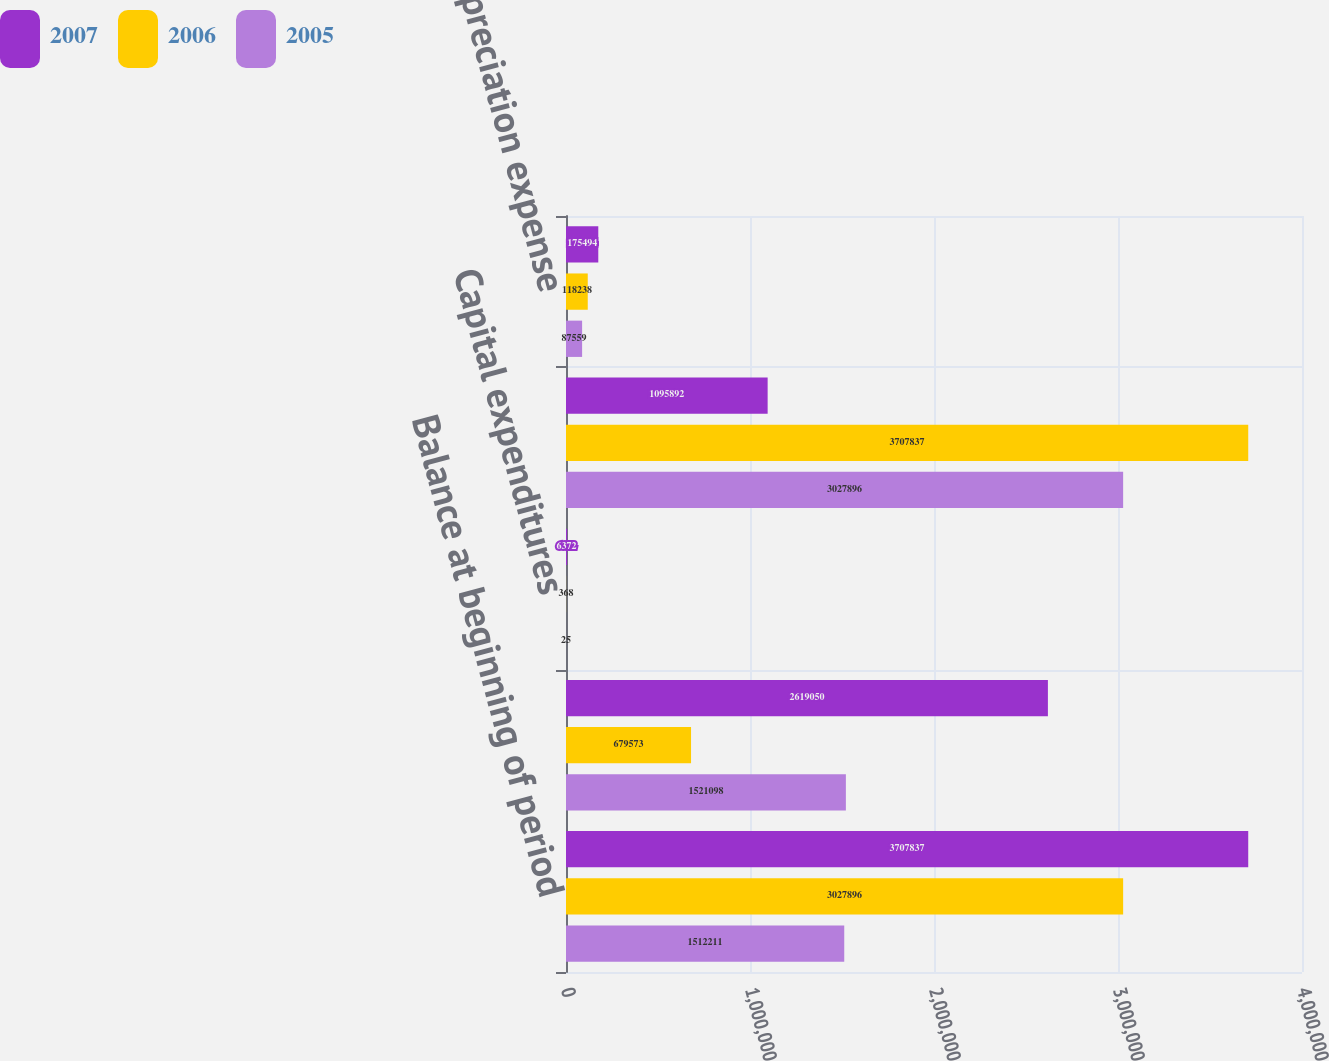Convert chart to OTSL. <chart><loc_0><loc_0><loc_500><loc_500><stacked_bar_chart><ecel><fcel>Balance at beginning of period<fcel>Acquisitions<fcel>Capital expenditures<fcel>Balance at end of period<fcel>Depreciation expense<nl><fcel>2007<fcel>3.70784e+06<fcel>2.61905e+06<fcel>6372<fcel>1.09589e+06<fcel>175494<nl><fcel>2006<fcel>3.0279e+06<fcel>679573<fcel>368<fcel>3.70784e+06<fcel>118238<nl><fcel>2005<fcel>1.51221e+06<fcel>1.5211e+06<fcel>25<fcel>3.0279e+06<fcel>87559<nl></chart> 